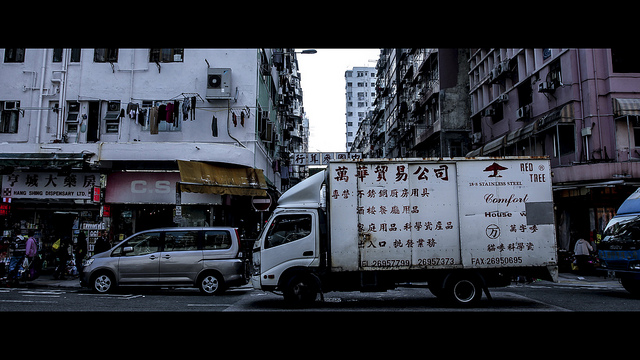Why does the large truck stop here? It's plausible that the traffic could cause the large truck to stop; however, without direct evidence in the image showing a traffic jam or indications of heavy traffic ahead, the provided answer remains somewhat speculative. The image doesn't clearly show if there's a traffic issue, if the truck has broken down, or if it's stopped for advertising or vehicle repairs. A more cautious and accurate answer would consider these possibilities, leading to the conclusion that we cannot determine the exact reason for the truck's stop with certainty from this single frame. 